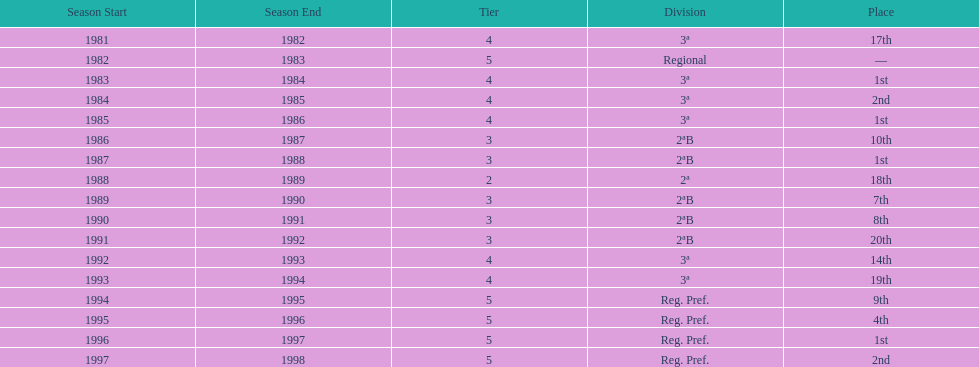In which year did the team have its worst season? 1991/92. 